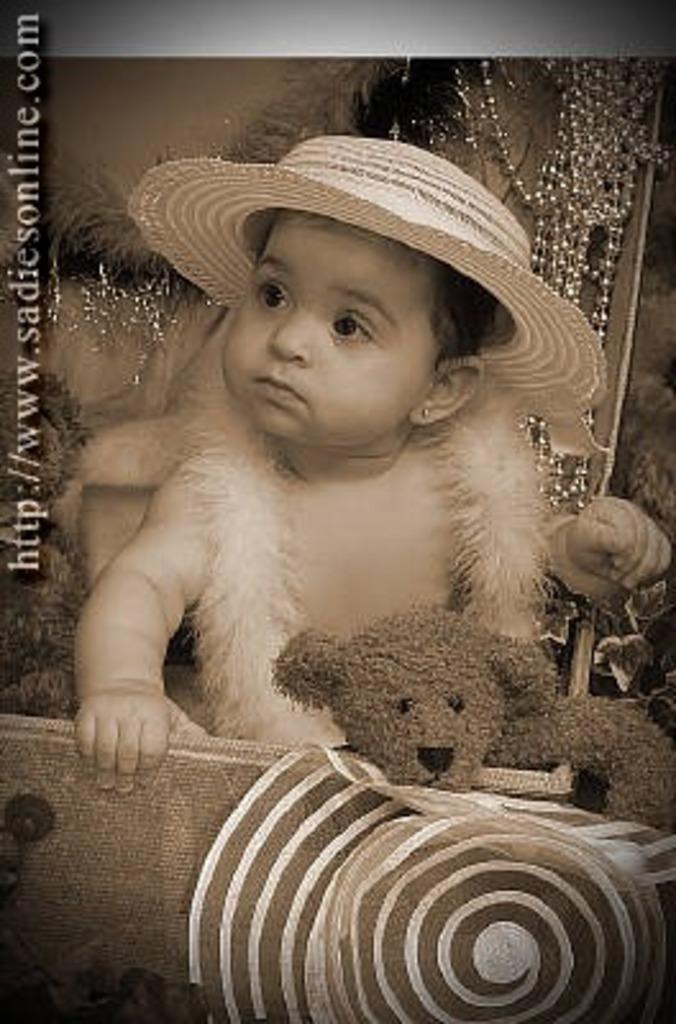How would you summarize this image in a sentence or two? In this image we can see a poster and on the poster we can see the picture of a baby holding some object and the baby is wearing a hat and there is a soft toy and we can see some other objects around her. We can see some text on the poster. 